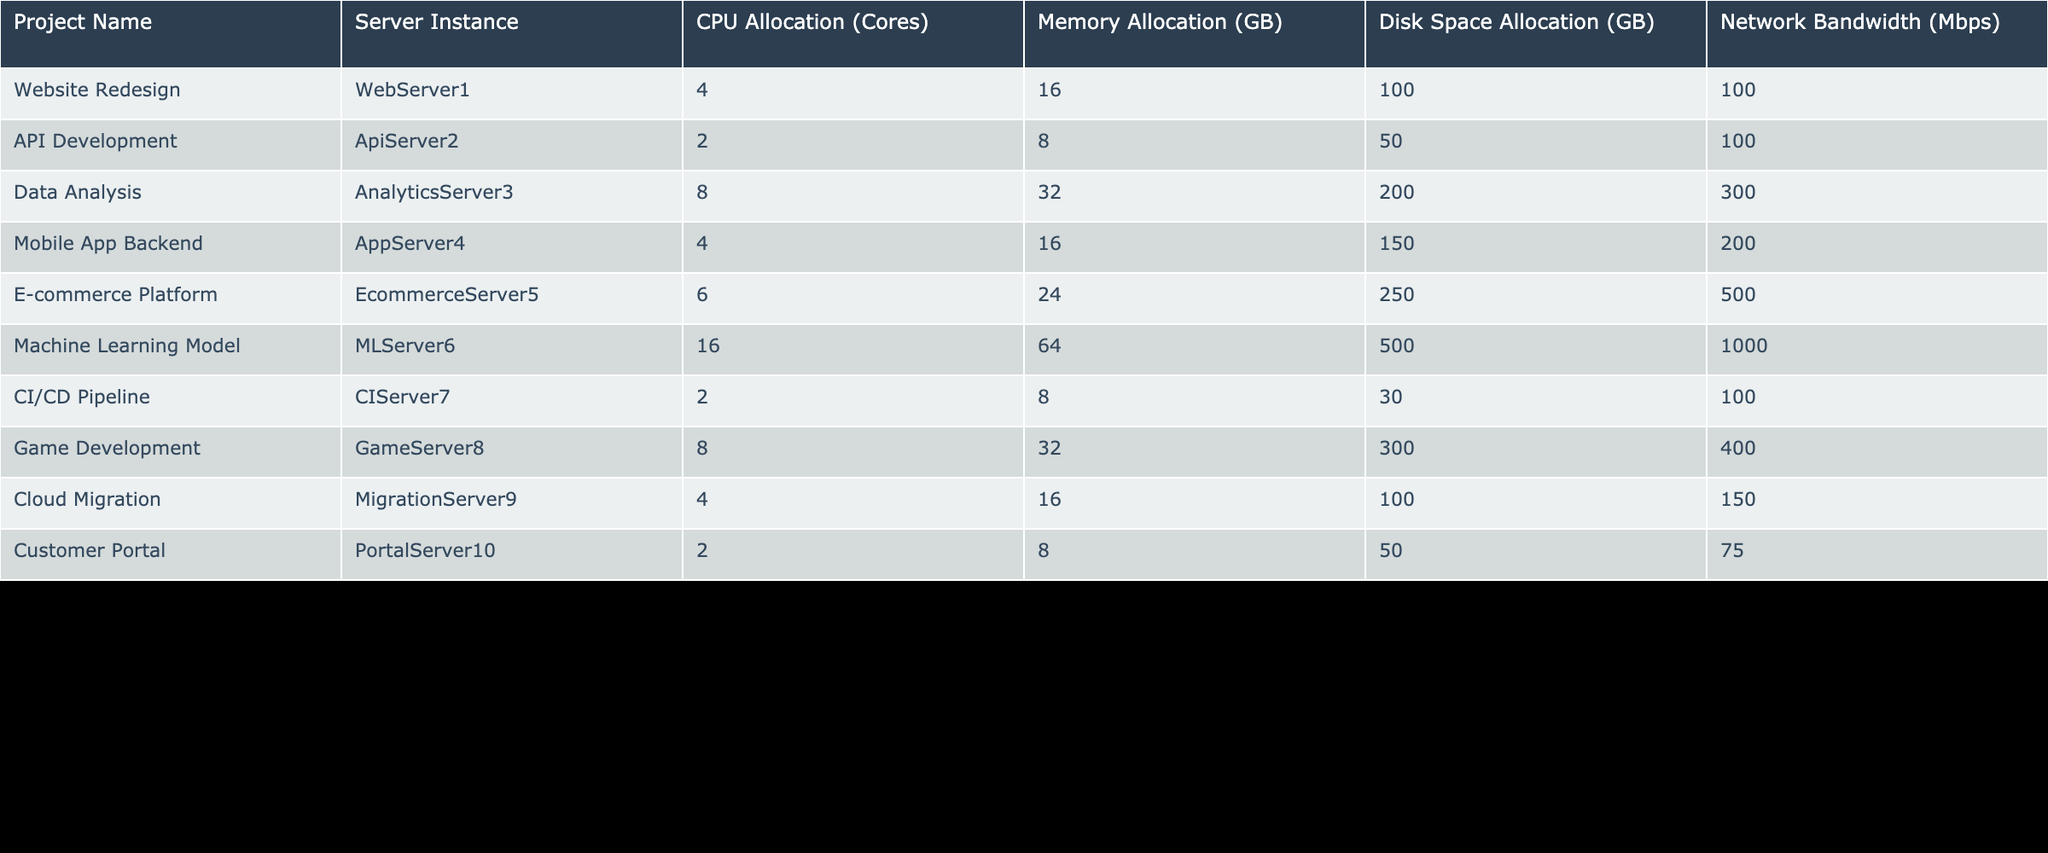What is the total CPU allocation across all projects? To find the total CPU allocation, we add up all the CPU allocations from the table: 4 + 2 + 8 + 4 + 6 + 16 + 2 + 8 + 4 + 2 = 56.
Answer: 56 Which project has the highest memory allocation? By examining the memory allocations in the table, the project "Machine Learning Model" has the highest allocation at 64 GB.
Answer: Machine Learning Model Is the disk space allocation for the "E-commerce Platform" greater than 200 GB? The table shows that the disk space allocation for the "E-commerce Platform" is 250 GB, which is greater than 200 GB.
Answer: Yes What is the average network bandwidth allocated to the projects? To find the average network bandwidth, add all the allocated bandwidth: 100 + 100 + 300 + 200 + 500 + 1000 + 100 + 400 + 150 + 75 = 3025. There are 10 projects, so the average is 3025 / 10 = 302.5.
Answer: 302.5 Which server instance is allocated the least CPU cores? The "ApiServer2", "CIServer7", and "PortalServer10" are all allocated 2 CPU cores, which is the least among the listed projects.
Answer: ApiServer2, CIServer7, PortalServer10 What is the total memory allocation for all mobile and web-related projects? The mobile project ("Mobile App Backend") has 16 GB and the web project ("Website Redesign") has 16 GB. Adding them up gives 16 + 16 = 32 GB.
Answer: 32 GB Is there a project that has more than 400 Mbps of network bandwidth? "Machine Learning Model" has 1000 Mbps, which is more than 400 Mbps.
Answer: Yes What is the difference in disk space allocation between the "Data Analysis" and "Game Development" projects? The "Data Analysis" project has 200 GB and "Game Development" has 300 GB. The difference is 300 - 200 = 100 GB.
Answer: 100 GB How many projects have a CPU allocation of 4 or fewer cores? By reviewing the table, the projects with 4 or fewer CPU cores are "Api Development", "CISD Pipeline", "Customer Portal", "Cloud Migration", and "Website Redesign", totaling 5 projects.
Answer: 5 